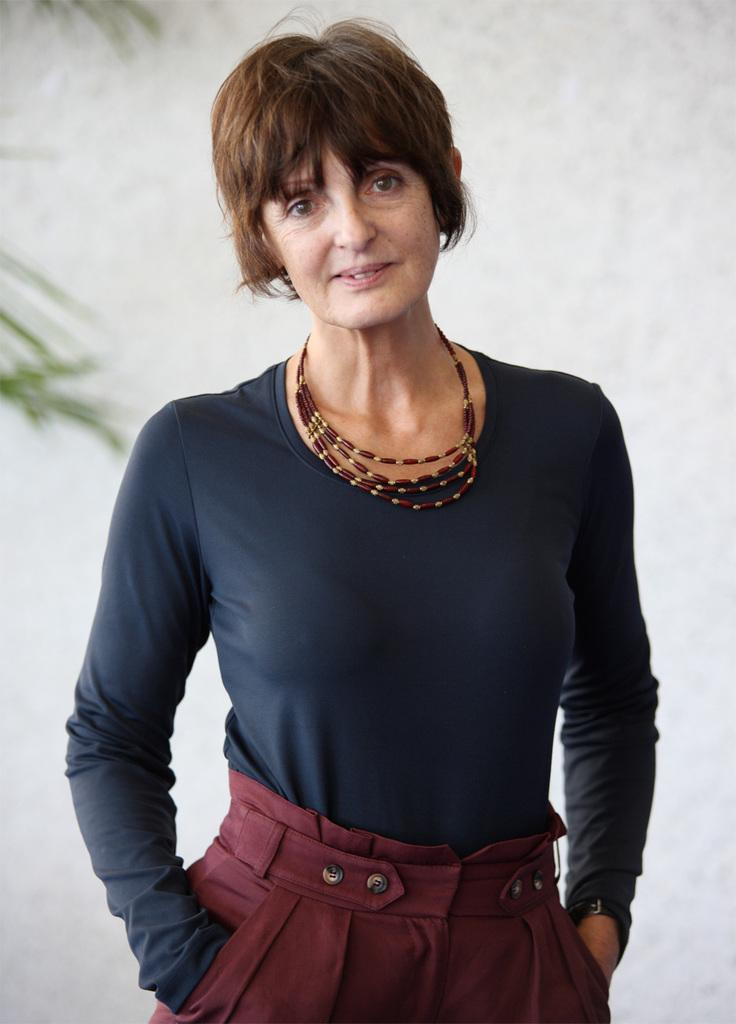What is the main subject of the image? There is a person standing in the image. What is the person's expression in the image? The person is smiling. What type of vegetation can be seen in the image? There are leaves visible in the image. What is in the background of the image? There is a wall in the background of the image. What type of cable can be seen connecting the person to the wall in the image? There is no cable connecting the person to the wall in the image. What type of leaf is the person holding in the image? There is no leaf present in the image. 